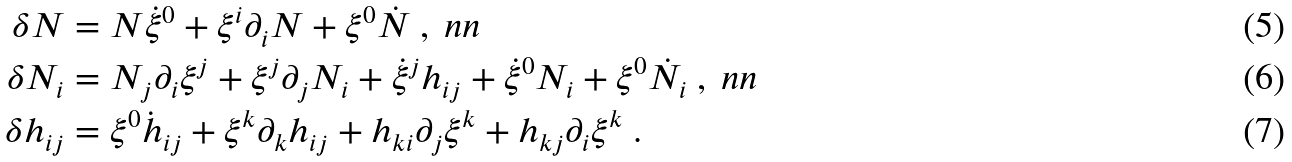<formula> <loc_0><loc_0><loc_500><loc_500>\delta N & = N \dot { \xi } ^ { 0 } + \xi ^ { i } \partial _ { i } N + \xi ^ { 0 } \dot { N } \ , \ n n \\ \delta N _ { i } & = N _ { j } \partial _ { i } \xi ^ { j } + \xi ^ { j } \partial _ { j } N _ { i } + \dot { \xi } ^ { j } h _ { i j } + \dot { \xi } ^ { 0 } N _ { i } + \xi ^ { 0 } \dot { N } _ { i } \ , \ n n \\ \delta h _ { i j } & = \xi ^ { 0 } \dot { h } _ { i j } + \xi ^ { k } \partial _ { k } h _ { i j } + h _ { k i } \partial _ { j } \xi ^ { k } + h _ { k j } \partial _ { i } \xi ^ { k } \ .</formula> 